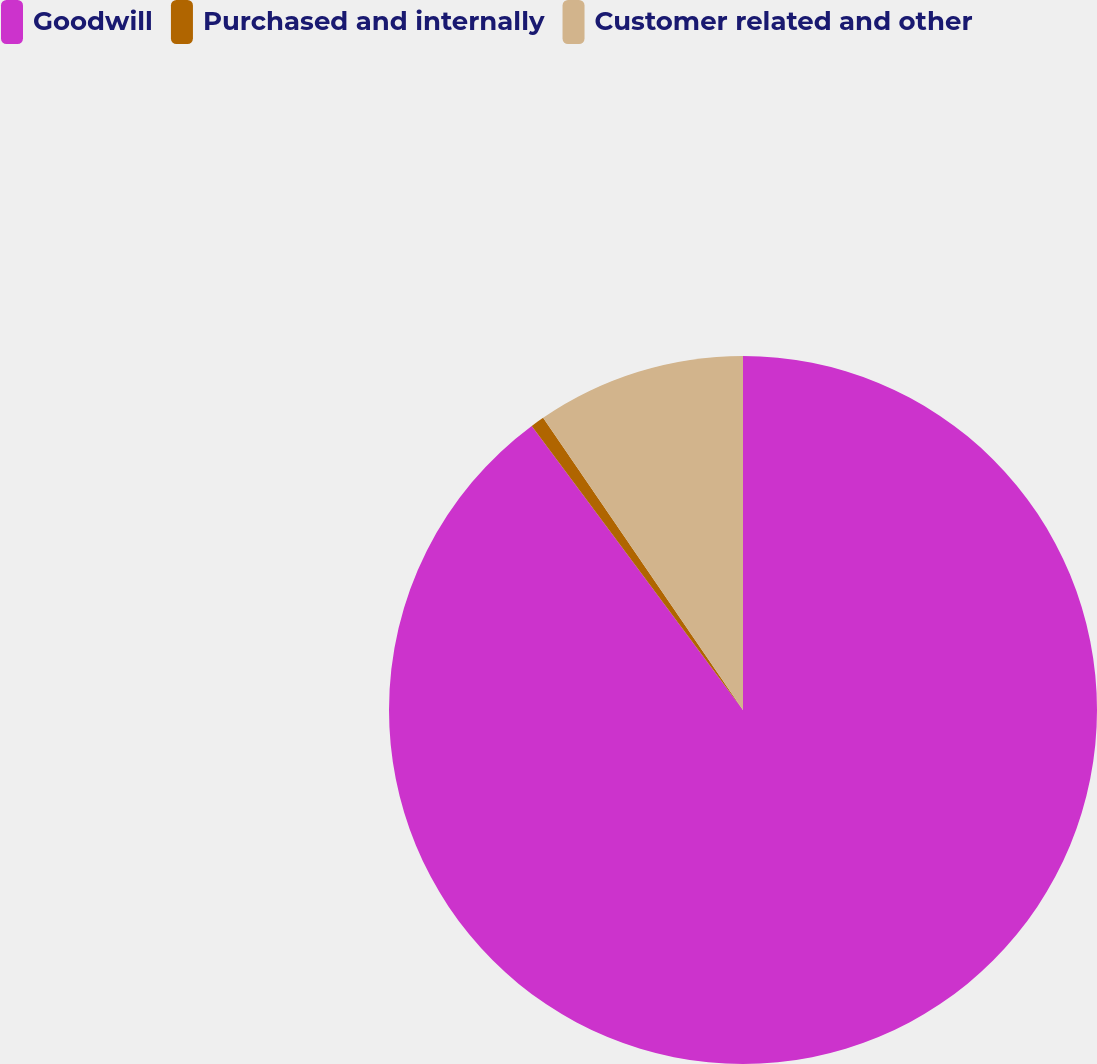Convert chart. <chart><loc_0><loc_0><loc_500><loc_500><pie_chart><fcel>Goodwill<fcel>Purchased and internally<fcel>Customer related and other<nl><fcel>89.83%<fcel>0.63%<fcel>9.55%<nl></chart> 